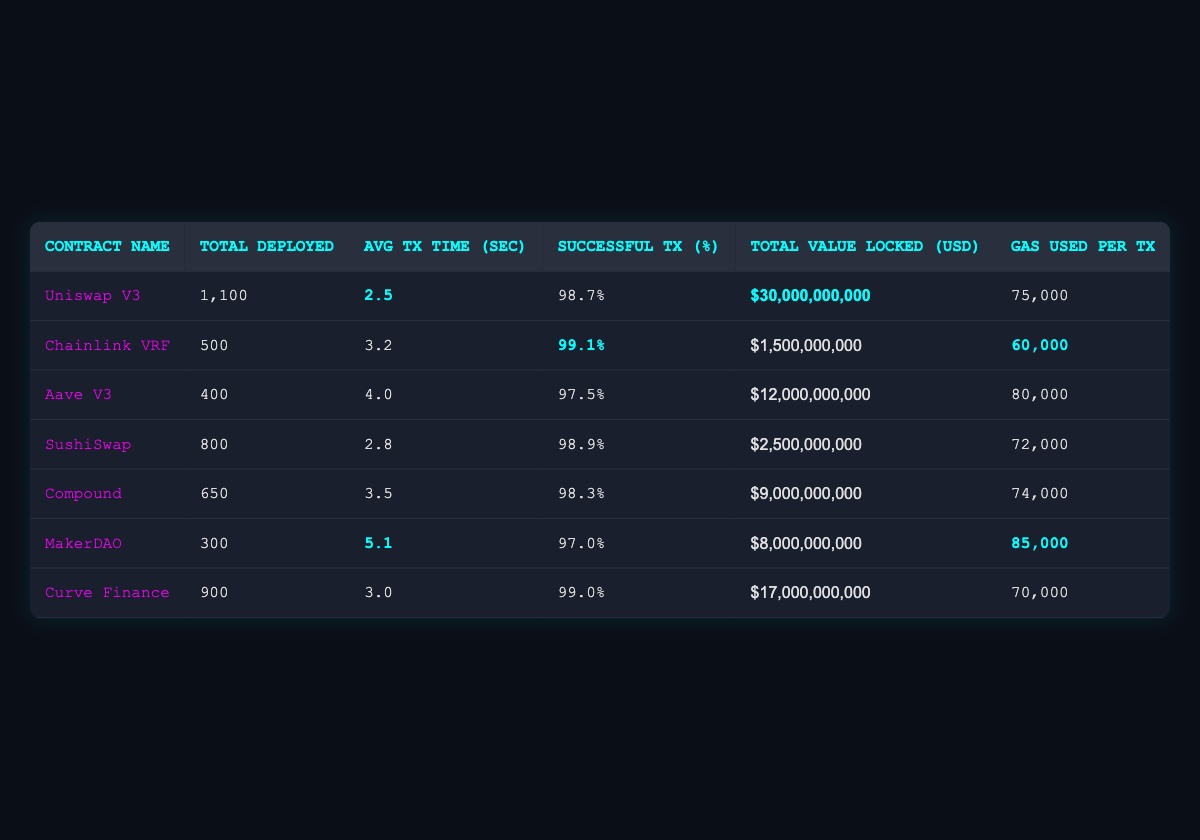What is the average transaction time of all contracts listed? To find the average transaction time, add the average transaction times of all contracts: (2.5 + 3.2 + 4.0 + 2.8 + 3.5 + 5.1 + 3.0) = 24.1 seconds. Then divide by the number of contracts (7): 24.1 / 7 ≈ 3.44 seconds.
Answer: 3.44 seconds Which contract has the highest successful transaction percentage? By inspecting the table, Chainlink VRF has the highest successful transaction percentage at 99.1%.
Answer: 99.1% What is the total value locked in Uniswap V3? The table shows that the total value locked in Uniswap V3 is $30,000,000,000.
Answer: $30,000,000,000 Is the average transaction time of MakerDAO greater than 4 seconds? The average transaction time for MakerDAO is 5.1 seconds, which is greater than 4 seconds, so the answer is yes.
Answer: Yes What is the difference in gas used per transaction between Compound and Aave V3? Aave V3 uses 80,000 gas per transaction and Compound uses 74,000 gas per transaction. The difference is 80,000 - 74,000 = 6,000.
Answer: 6,000 Which contract has the lowest successful transaction percentage, and what is that percentage? By reviewing the table, MakerDAO has the lowest successful transaction percentage at 97.0%.
Answer: MakerDAO, 97.0% What is the total number of contracts deployed for sushi-related platforms? The sushi-related platforms are SushiSwap and Uniswap V3; the total contracts deployed are 800 (SushiSwap) + 1100 (Uniswap V3) = 1900.
Answer: 1900 What percentage of contracts have a successful transaction percentage greater than 98%? The contracts with successful transaction percentages greater than 98% are Uniswap V3, Chainlink VRF, SushiSwap, and Curve Finance (4 contracts total). Out of 7 total contracts, the percentage is (4/7) * 100 ≈ 57.14%.
Answer: 57.14% What is the total USD value locked in all contracts combined? To find this, sum the values locked: 30,000,000,000 + 1,500,000,000 + 12,000,000,000 + 2,500,000,000 + 9,000,000,000 + 8,000,000,000 + 17,000,000,000 = 80,000,000,000.
Answer: $80,000,000,000 If the gas used per transaction were to be optimized for both Uniswap V3 and Curve Finance, what would be their new average if optimized to 70,000 each? Optimizing both to 70,000 means their sum becomes: 70,000 (Uniswap V3) + 70,000 (Curve Finance) = 140,000. Divide by the 2 contracts to get the new average: 140,000 / 2 = 70,000.
Answer: 70,000 